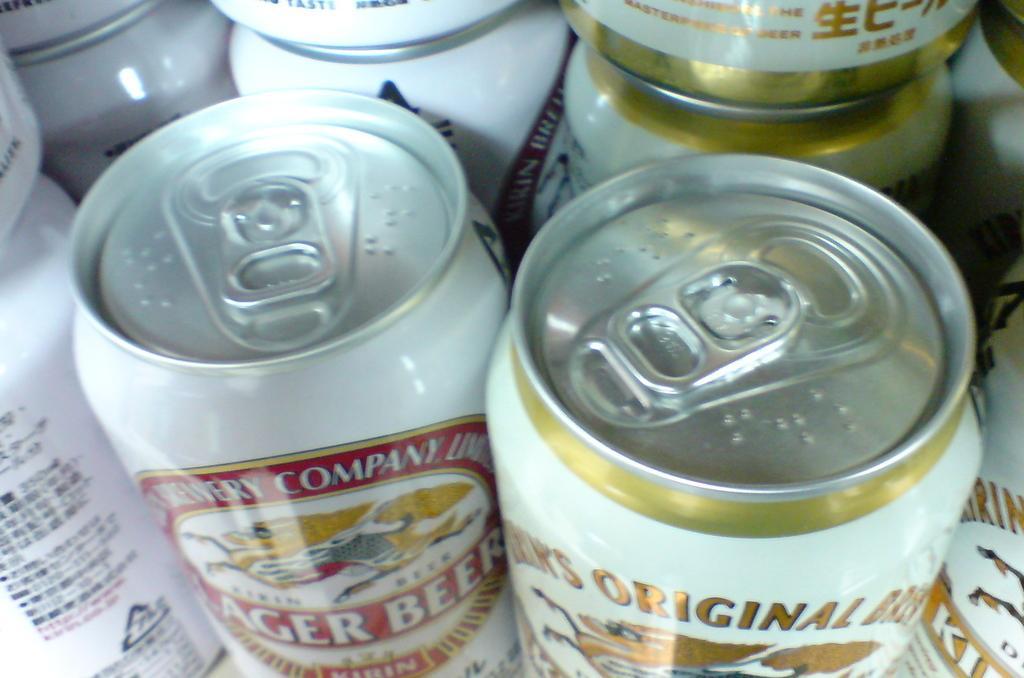Please provide a concise description of this image. In this image I can see few cool-drink tins which are white in color and something is printed on them. 